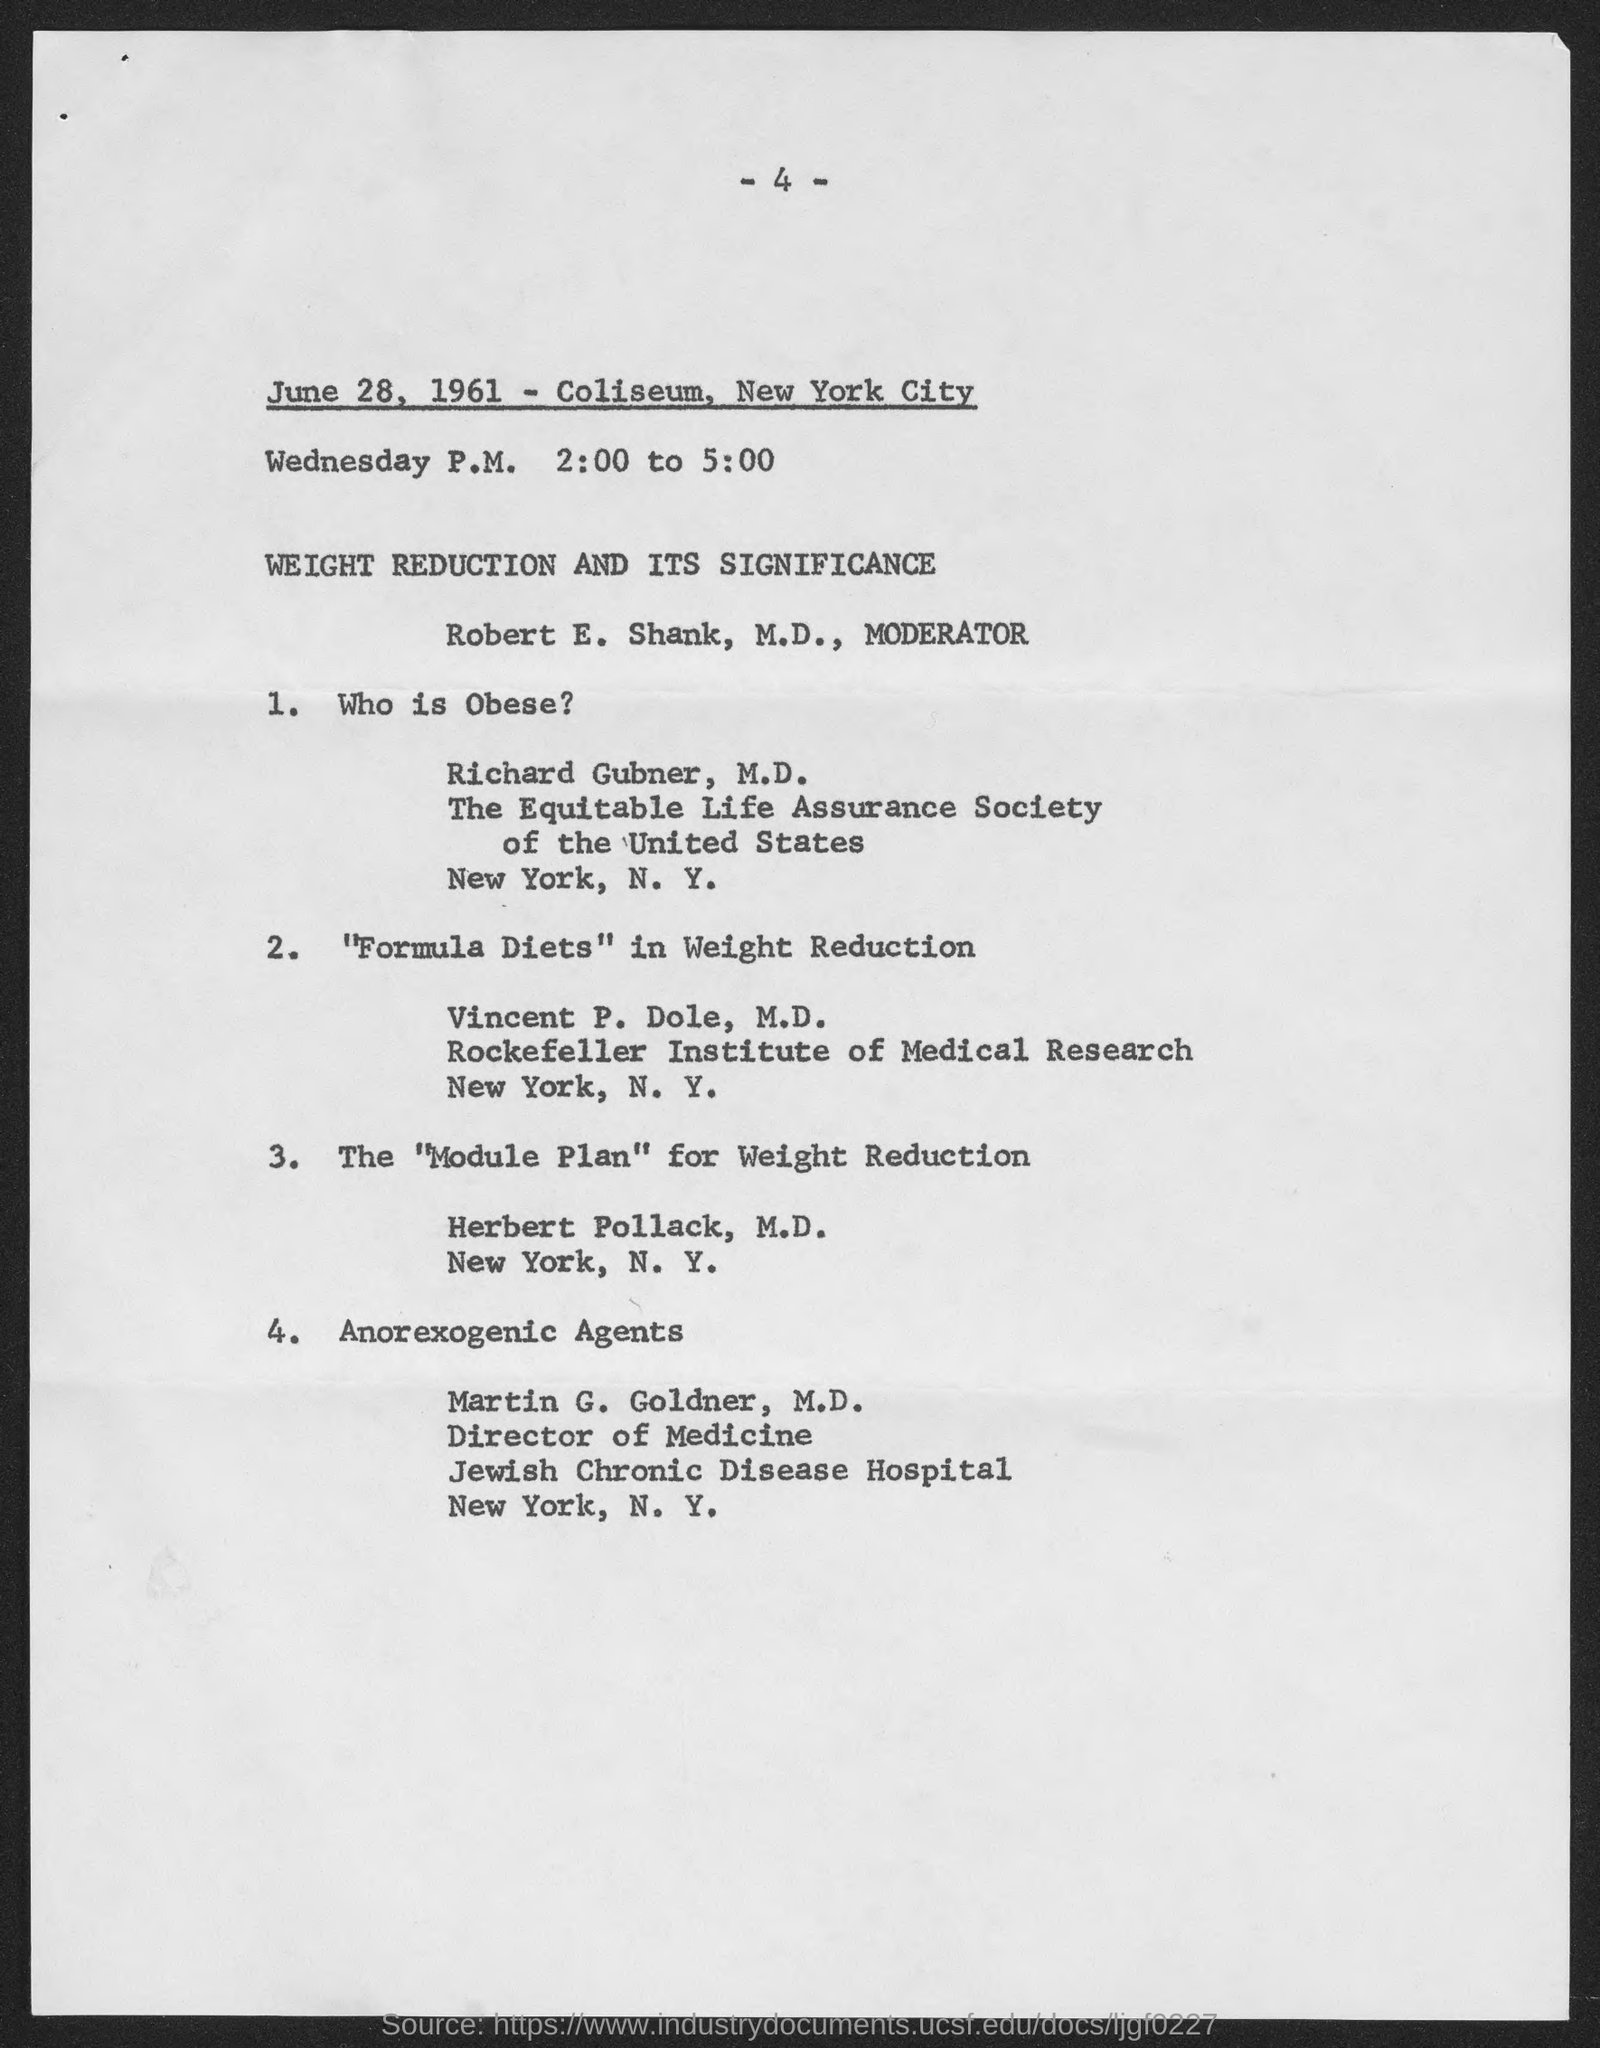Mention the "date ,month and year" shown in the document ?
Make the answer very short. June 28, 1961. Where this program is conducted ?
Your answer should be compact. Coliseum, new york city. Which person is "obese" ?
Ensure brevity in your answer.  Richard gubner. Who is the "moderator" ?
Your answer should be very brief. Robert e. shank. Who is the "Director of Medicine" ?
Offer a very short reply. Martin G. Goldner, M.D. In which hospital, does the "Anorexogenic Agents" works ?
Keep it short and to the point. Jewish chronic disease hospital. For what purpose, " Formula Diets" are created ?
Make the answer very short. Weight Reduction. 